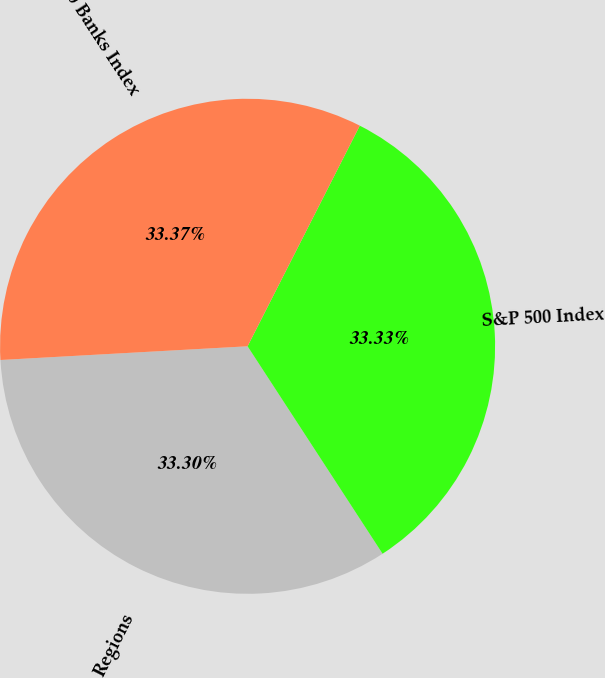Convert chart to OTSL. <chart><loc_0><loc_0><loc_500><loc_500><pie_chart><fcel>Regions<fcel>S&P 500 Index<fcel>S&P 500 Banks Index<nl><fcel>33.3%<fcel>33.33%<fcel>33.37%<nl></chart> 